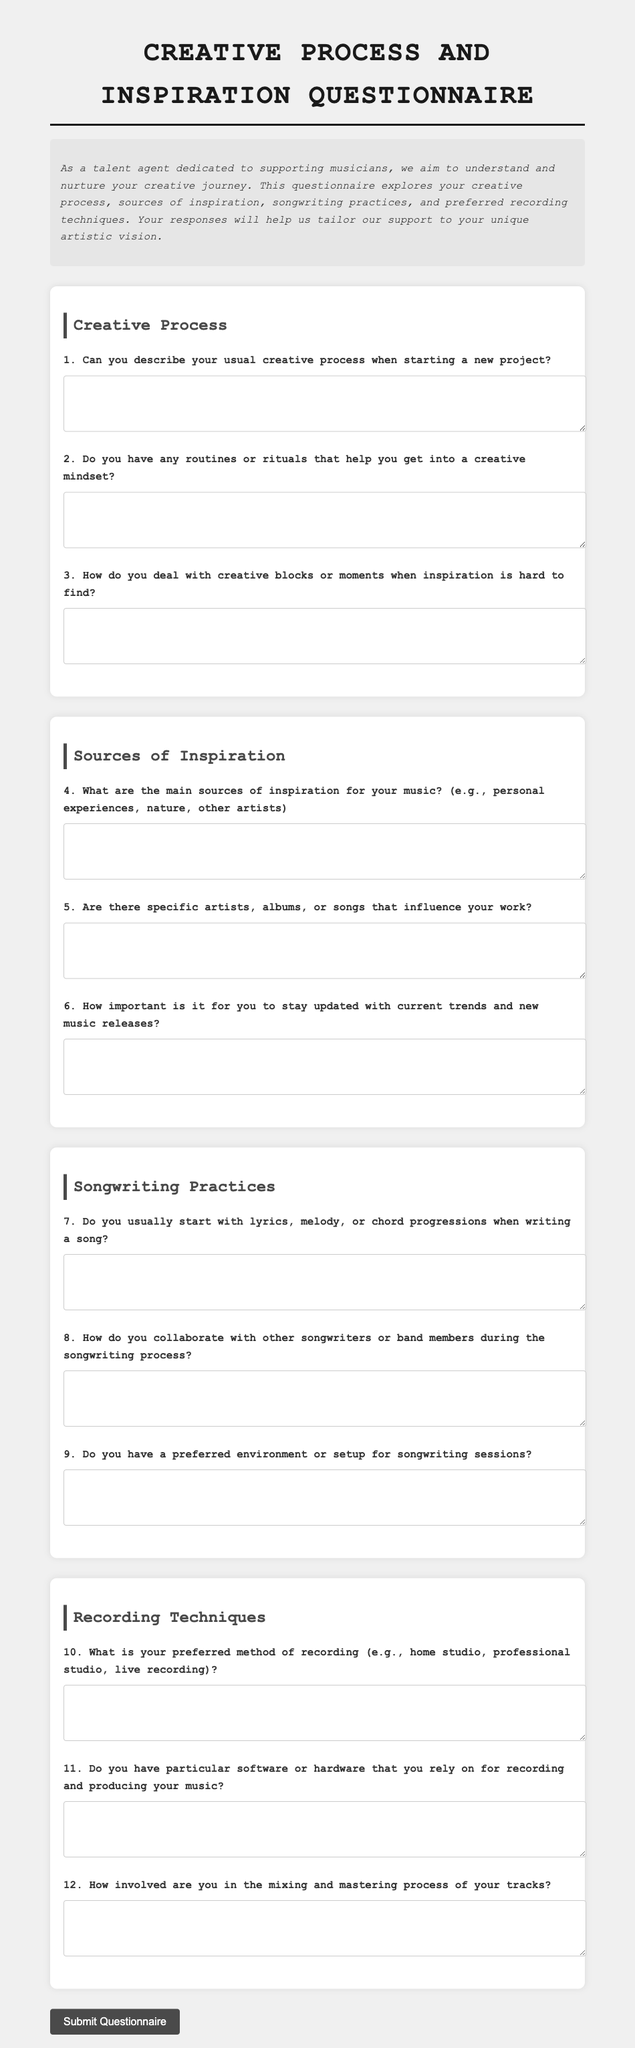What is the title of the document? The title of the document is presented in the main heading at the top of the page.
Answer: Creative Process and Inspiration Questionnaire What are the main sections outlined in the questionnaire? The main sections provide an organized structure for the questionnaire, detailing various aspects of musicianship.
Answer: Creative Process, Sources of Inspiration, Songwriting Practices, Recording Techniques How many questions are there in the Creative Process section? The number of questions can be found by counting the individual questions listed within the section.
Answer: 3 What type of question is question 8? The type of question indicates the focus of inquiry related to the songwriting process among collaborators.
Answer: Collaboration What is the primary purpose of the questionnaire? The purpose reflects the overall intention behind collecting the responses from musicians in the document.
Answer: To understand and nurture the creative journey of musicians How does the document ask for responses? The method for gathering responses is outlined at the end of the questionnaire and indicates user interaction.
Answer: Textarea for short answers How is the document visually structured? The visual structure is defined by the different sections and their titles being prominently displayed, aiding navigation.
Answer: Sectioned layout with headings What does the button at the end of the form do? The action performed by the button at the end can be interpreted based on its labeling.
Answer: Submit Questionnaire 